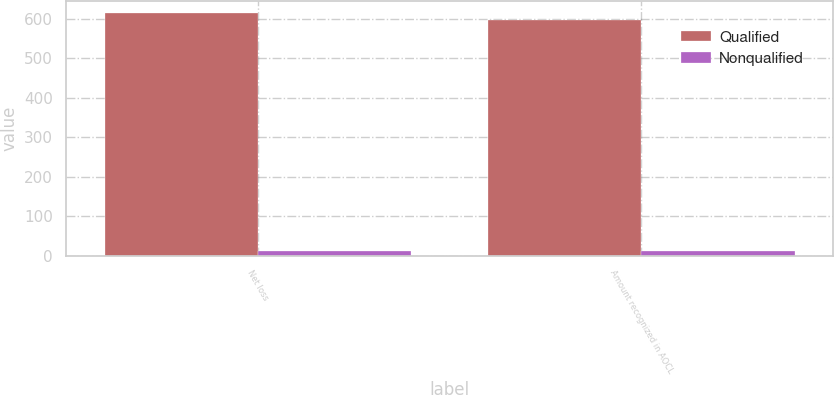Convert chart. <chart><loc_0><loc_0><loc_500><loc_500><stacked_bar_chart><ecel><fcel>Net loss<fcel>Amount recognized in AOCL<nl><fcel>Qualified<fcel>613.2<fcel>597.5<nl><fcel>Nonqualified<fcel>11.5<fcel>11.5<nl></chart> 